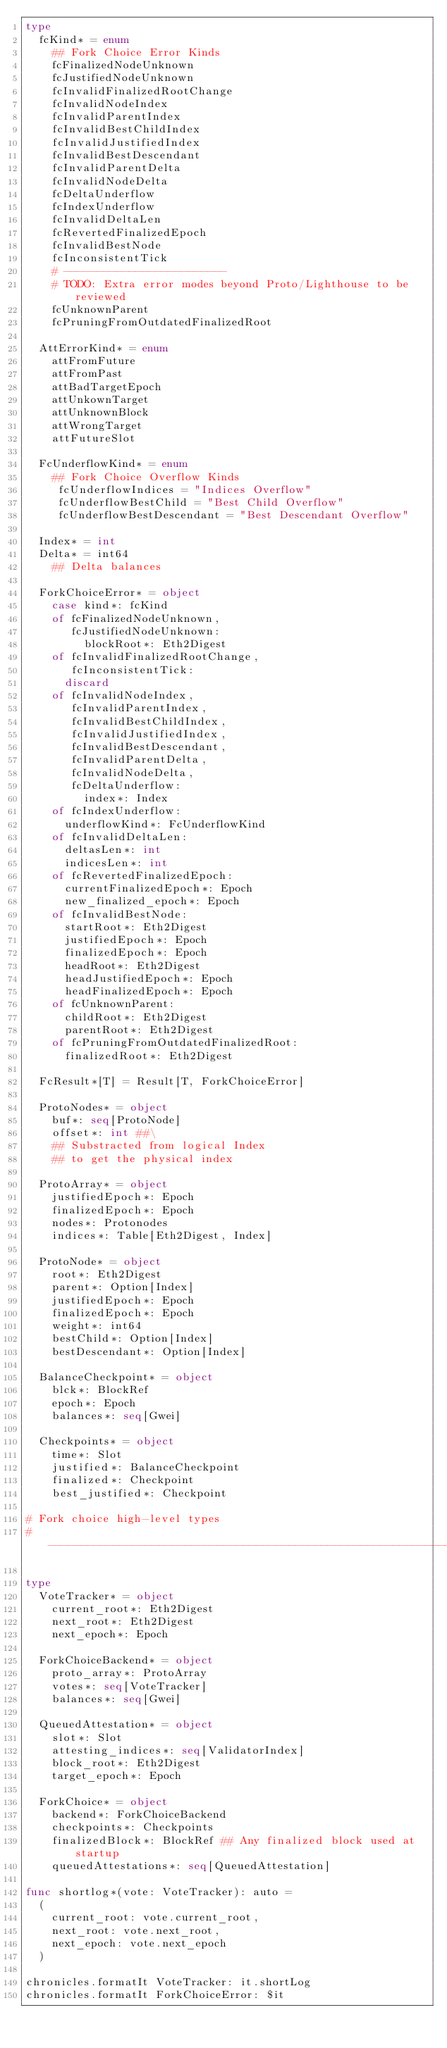Convert code to text. <code><loc_0><loc_0><loc_500><loc_500><_Nim_>type
  fcKind* = enum
    ## Fork Choice Error Kinds
    fcFinalizedNodeUnknown
    fcJustifiedNodeUnknown
    fcInvalidFinalizedRootChange
    fcInvalidNodeIndex
    fcInvalidParentIndex
    fcInvalidBestChildIndex
    fcInvalidJustifiedIndex
    fcInvalidBestDescendant
    fcInvalidParentDelta
    fcInvalidNodeDelta
    fcDeltaUnderflow
    fcIndexUnderflow
    fcInvalidDeltaLen
    fcRevertedFinalizedEpoch
    fcInvalidBestNode
    fcInconsistentTick
    # -------------------------
    # TODO: Extra error modes beyond Proto/Lighthouse to be reviewed
    fcUnknownParent
    fcPruningFromOutdatedFinalizedRoot

  AttErrorKind* = enum
    attFromFuture
    attFromPast
    attBadTargetEpoch
    attUnkownTarget
    attUnknownBlock
    attWrongTarget
    attFutureSlot

  FcUnderflowKind* = enum
    ## Fork Choice Overflow Kinds
     fcUnderflowIndices = "Indices Overflow"
     fcUnderflowBestChild = "Best Child Overflow"
     fcUnderflowBestDescendant = "Best Descendant Overflow"

  Index* = int
  Delta* = int64
    ## Delta balances

  ForkChoiceError* = object
    case kind*: fcKind
    of fcFinalizedNodeUnknown,
       fcJustifiedNodeUnknown:
         blockRoot*: Eth2Digest
    of fcInvalidFinalizedRootChange,
       fcInconsistentTick:
      discard
    of fcInvalidNodeIndex,
       fcInvalidParentIndex,
       fcInvalidBestChildIndex,
       fcInvalidJustifiedIndex,
       fcInvalidBestDescendant,
       fcInvalidParentDelta,
       fcInvalidNodeDelta,
       fcDeltaUnderflow:
         index*: Index
    of fcIndexUnderflow:
      underflowKind*: FcUnderflowKind
    of fcInvalidDeltaLen:
      deltasLen*: int
      indicesLen*: int
    of fcRevertedFinalizedEpoch:
      currentFinalizedEpoch*: Epoch
      new_finalized_epoch*: Epoch
    of fcInvalidBestNode:
      startRoot*: Eth2Digest
      justifiedEpoch*: Epoch
      finalizedEpoch*: Epoch
      headRoot*: Eth2Digest
      headJustifiedEpoch*: Epoch
      headFinalizedEpoch*: Epoch
    of fcUnknownParent:
      childRoot*: Eth2Digest
      parentRoot*: Eth2Digest
    of fcPruningFromOutdatedFinalizedRoot:
      finalizedRoot*: Eth2Digest

  FcResult*[T] = Result[T, ForkChoiceError]

  ProtoNodes* = object
    buf*: seq[ProtoNode]
    offset*: int ##\
    ## Substracted from logical Index
    ## to get the physical index

  ProtoArray* = object
    justifiedEpoch*: Epoch
    finalizedEpoch*: Epoch
    nodes*: Protonodes
    indices*: Table[Eth2Digest, Index]

  ProtoNode* = object
    root*: Eth2Digest
    parent*: Option[Index]
    justifiedEpoch*: Epoch
    finalizedEpoch*: Epoch
    weight*: int64
    bestChild*: Option[Index]
    bestDescendant*: Option[Index]

  BalanceCheckpoint* = object
    blck*: BlockRef
    epoch*: Epoch
    balances*: seq[Gwei]

  Checkpoints* = object
    time*: Slot
    justified*: BalanceCheckpoint
    finalized*: Checkpoint
    best_justified*: Checkpoint

# Fork choice high-level types
# ----------------------------------------------------------------------

type
  VoteTracker* = object
    current_root*: Eth2Digest
    next_root*: Eth2Digest
    next_epoch*: Epoch

  ForkChoiceBackend* = object
    proto_array*: ProtoArray
    votes*: seq[VoteTracker]
    balances*: seq[Gwei]

  QueuedAttestation* = object
    slot*: Slot
    attesting_indices*: seq[ValidatorIndex]
    block_root*: Eth2Digest
    target_epoch*: Epoch

  ForkChoice* = object
    backend*: ForkChoiceBackend
    checkpoints*: Checkpoints
    finalizedBlock*: BlockRef ## Any finalized block used at startup
    queuedAttestations*: seq[QueuedAttestation]

func shortlog*(vote: VoteTracker): auto =
  (
    current_root: vote.current_root,
    next_root: vote.next_root,
    next_epoch: vote.next_epoch
  )

chronicles.formatIt VoteTracker: it.shortLog
chronicles.formatIt ForkChoiceError: $it
</code> 